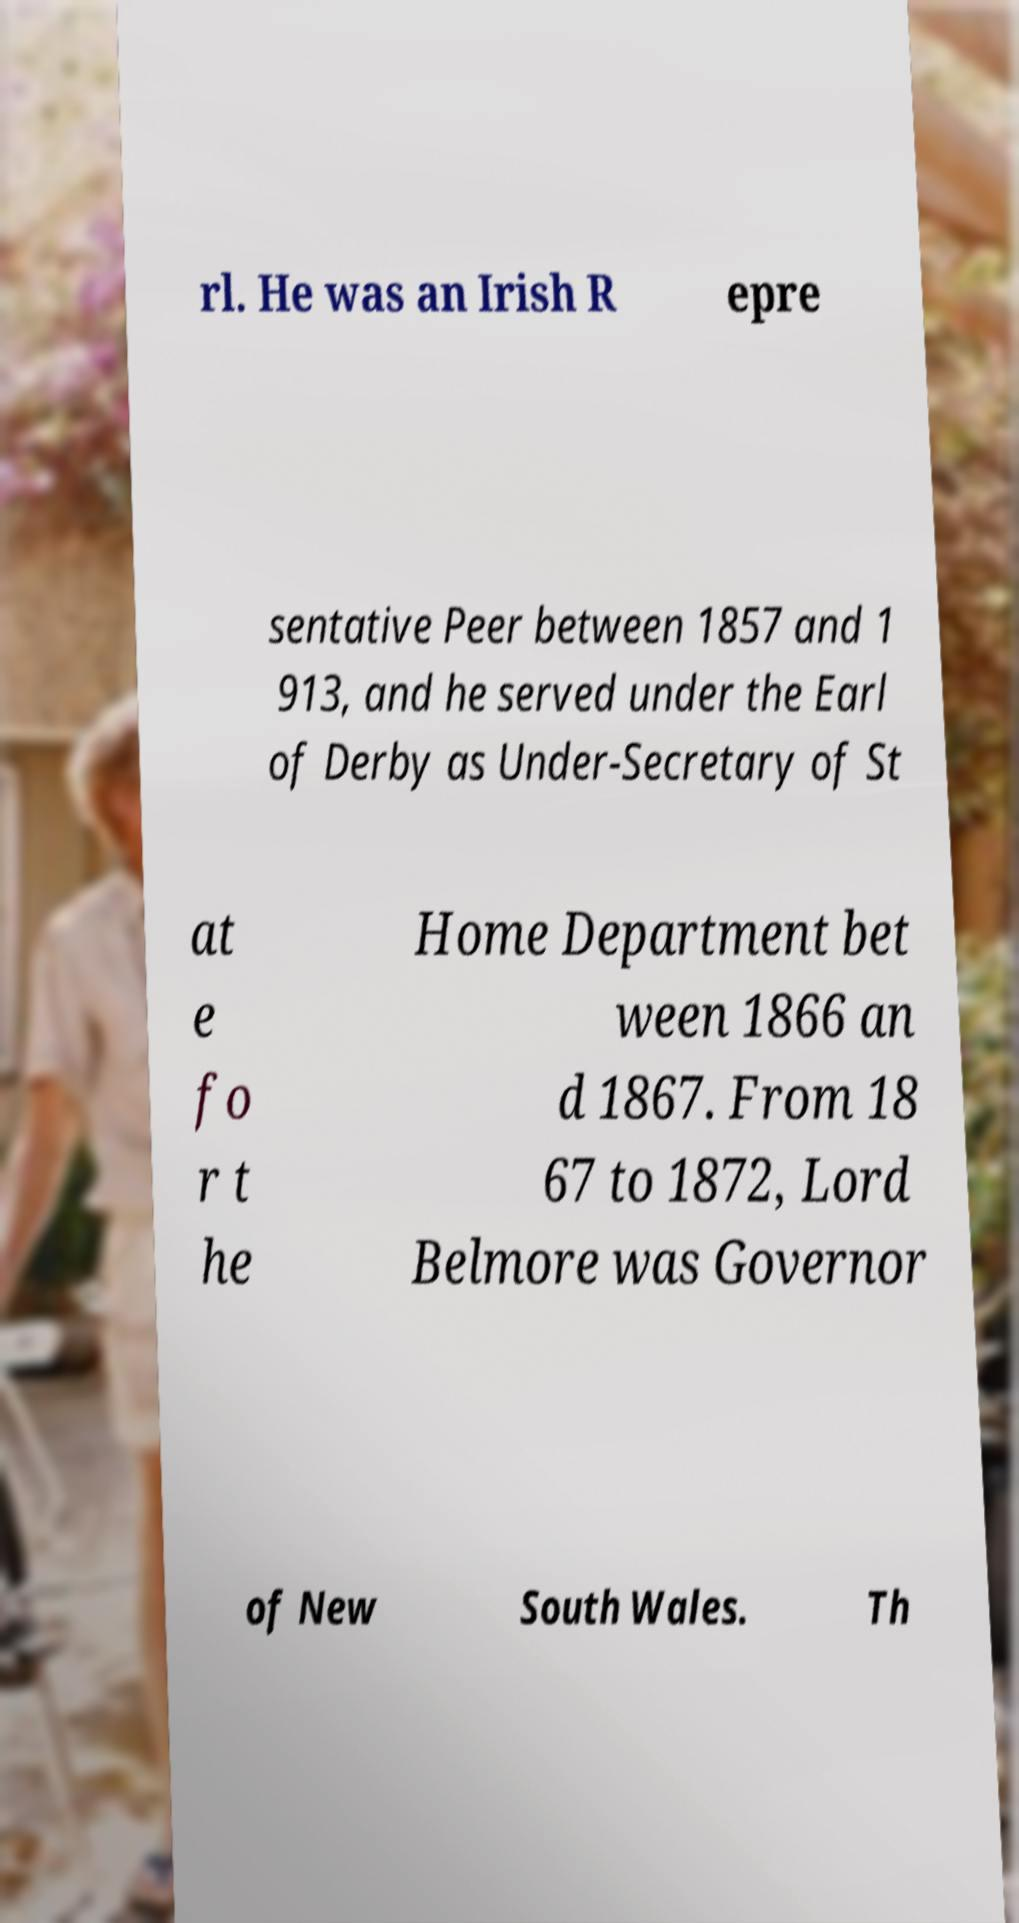Can you accurately transcribe the text from the provided image for me? rl. He was an Irish R epre sentative Peer between 1857 and 1 913, and he served under the Earl of Derby as Under-Secretary of St at e fo r t he Home Department bet ween 1866 an d 1867. From 18 67 to 1872, Lord Belmore was Governor of New South Wales. Th 